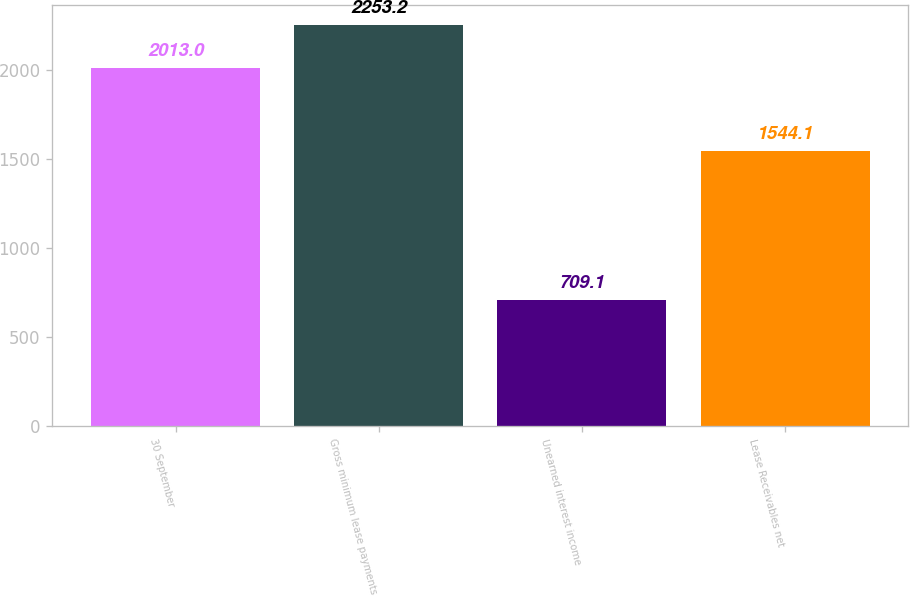Convert chart to OTSL. <chart><loc_0><loc_0><loc_500><loc_500><bar_chart><fcel>30 September<fcel>Gross minimum lease payments<fcel>Unearned interest income<fcel>Lease Receivables net<nl><fcel>2013<fcel>2253.2<fcel>709.1<fcel>1544.1<nl></chart> 